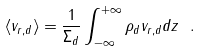Convert formula to latex. <formula><loc_0><loc_0><loc_500><loc_500>\langle v _ { r , d } \rangle = \frac { 1 } { \Sigma _ { d } } \int _ { - \infty } ^ { + \infty } \rho _ { d } v _ { r , d } d z \ .</formula> 